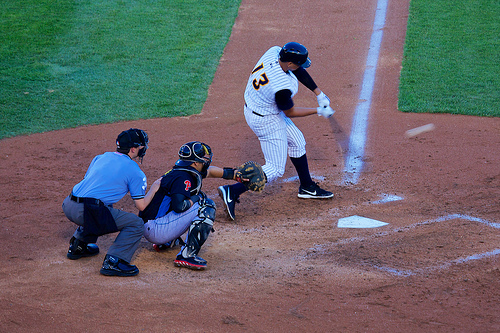Can you describe the action captured in this image concerning the baseball game? The image captures a crucial moment in a baseball game, showing a batter in mid-swing, a catcher ready to receive the ball, and an umpire closely observing the play. The focus and intensity suggest it’s a significant point in the game, possibly with high stakes on the pitch. 